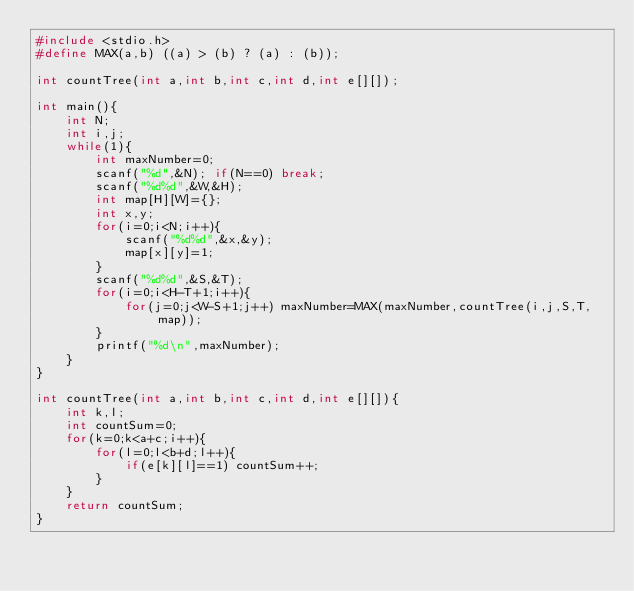Convert code to text. <code><loc_0><loc_0><loc_500><loc_500><_C_>#include <stdio.h>
#define MAX(a,b) ((a) > (b) ? (a) : (b));

int countTree(int a,int b,int c,int d,int e[][]);

int main(){
	int N;
	int i,j;
	while(1){
		int maxNumber=0;
		scanf("%d",&N); if(N==0) break;
		scanf("%d%d",&W,&H);
		int map[H][W]={};
		int x,y;
		for(i=0;i<N;i++){
			scanf("%d%d",&x,&y);
			map[x][y]=1;
		}
		scanf("%d%d",&S,&T);
		for(i=0;i<H-T+1;i++){
			for(j=0;j<W-S+1;j++) maxNumber=MAX(maxNumber,countTree(i,j,S,T,map));
		}
		printf("%d\n",maxNumber);
	}
}

int countTree(int a,int b,int c,int d,int e[][]){
	int k,l;
	int countSum=0;
	for(k=0;k<a+c;i++){
		for(l=0;l<b+d;l++){
			if(e[k][l]==1) countSum++;
		}
	}
	return countSum;
}</code> 